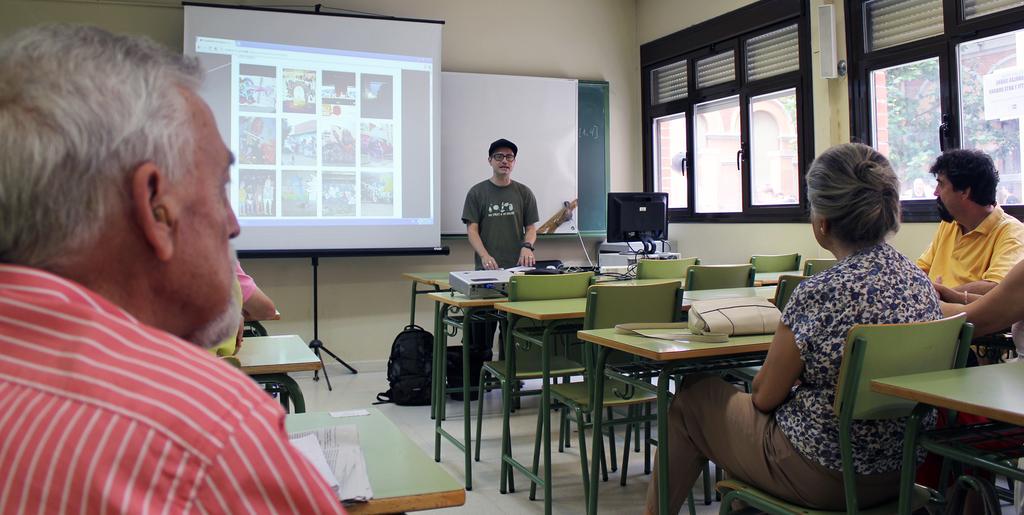Describe this image in one or two sentences. In this picture we see 5 to 6 people and person at the center is presenting something on the screen there. Here we have video player. These remaining people are listening. In this image we have tables, chairs present. Also we have laptop. It seems like a classroom. 